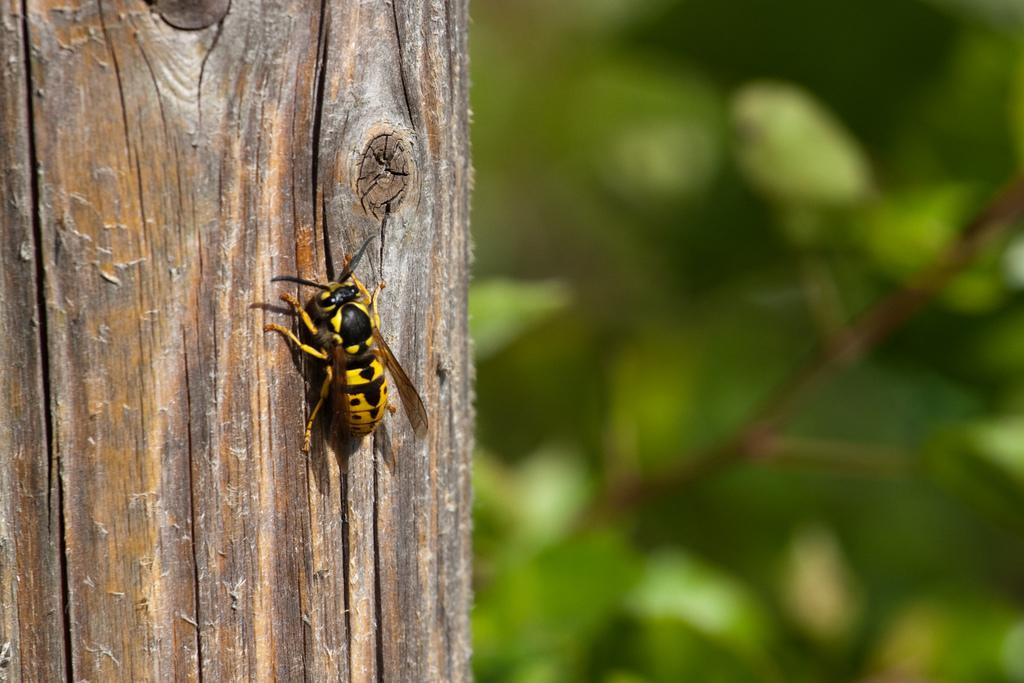What is the main subject of the image? There is an insect in the image. Where is the insect located? The insect is on a tree trunk. What can be observed in the background of the image? The background of the image appears green and blurry. What type of creature is depicted on the page in the image? There is no page present in the image, and therefore no creature can be depicted on it. 